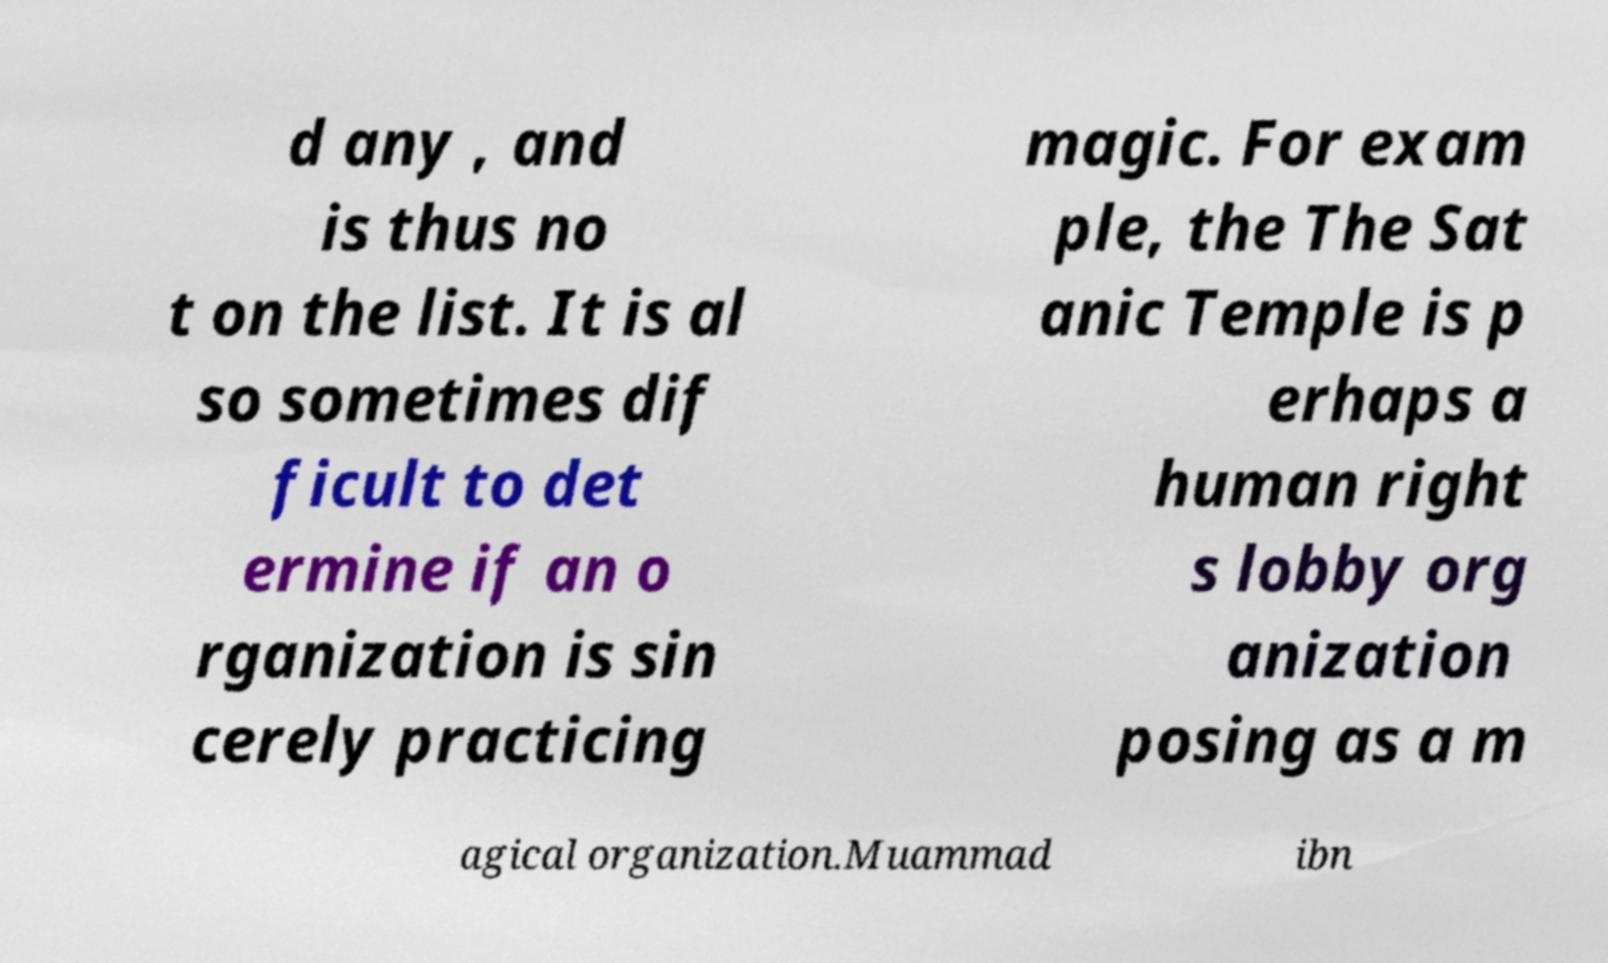Could you assist in decoding the text presented in this image and type it out clearly? d any , and is thus no t on the list. It is al so sometimes dif ficult to det ermine if an o rganization is sin cerely practicing magic. For exam ple, the The Sat anic Temple is p erhaps a human right s lobby org anization posing as a m agical organization.Muammad ibn 